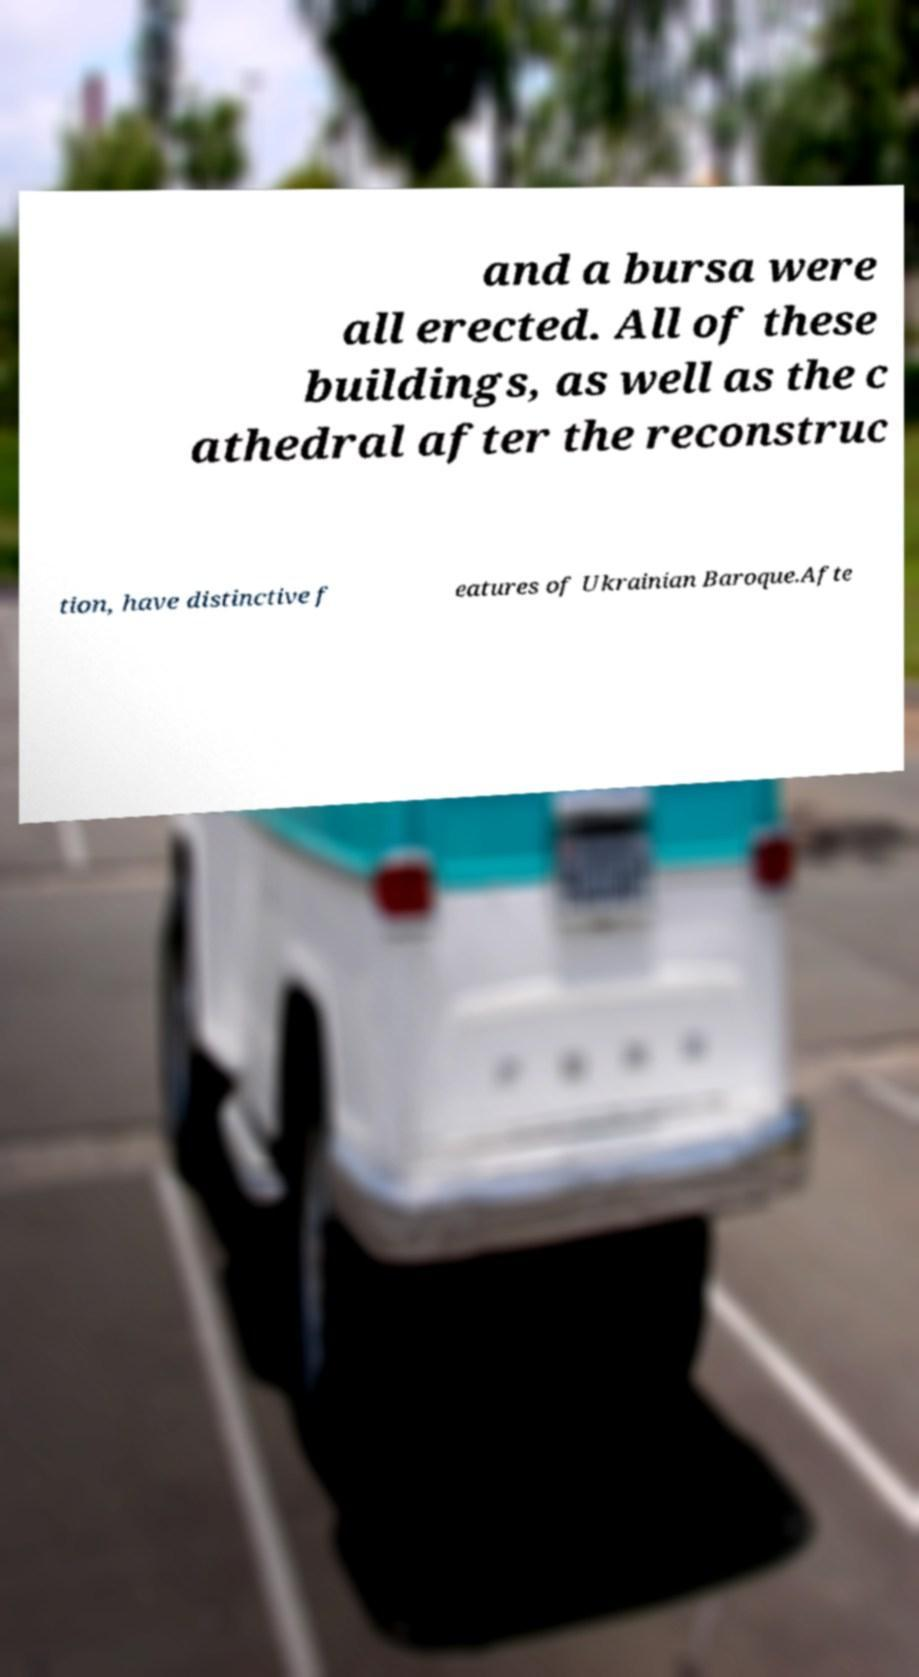Please read and relay the text visible in this image. What does it say? and a bursa were all erected. All of these buildings, as well as the c athedral after the reconstruc tion, have distinctive f eatures of Ukrainian Baroque.Afte 